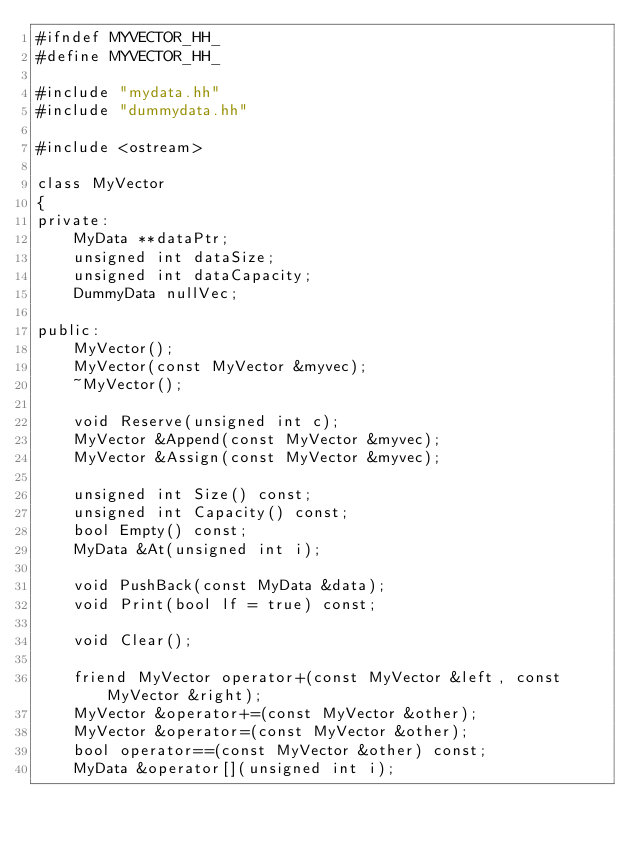Convert code to text. <code><loc_0><loc_0><loc_500><loc_500><_C++_>#ifndef MYVECTOR_HH_
#define MYVECTOR_HH_

#include "mydata.hh"
#include "dummydata.hh"

#include <ostream>

class MyVector
{
private:
    MyData **dataPtr;
    unsigned int dataSize;
    unsigned int dataCapacity;
    DummyData nullVec;

public:
    MyVector();
    MyVector(const MyVector &myvec);
    ~MyVector();

    void Reserve(unsigned int c);
    MyVector &Append(const MyVector &myvec);
    MyVector &Assign(const MyVector &myvec);

    unsigned int Size() const;
    unsigned int Capacity() const;
    bool Empty() const;
    MyData &At(unsigned int i);

    void PushBack(const MyData &data);
    void Print(bool lf = true) const;

    void Clear();

    friend MyVector operator+(const MyVector &left, const MyVector &right);
    MyVector &operator+=(const MyVector &other);
    MyVector &operator=(const MyVector &other);
    bool operator==(const MyVector &other) const;
    MyData &operator[](unsigned int i);</code> 